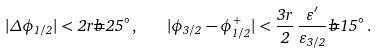Convert formula to latex. <formula><loc_0><loc_0><loc_500><loc_500>| \Delta \phi _ { 1 / 2 } | < 2 r \widehat { = } 2 5 ^ { \circ } \, , \quad | \phi _ { 3 / 2 } - \phi _ { 1 / 2 } ^ { + } | < \frac { 3 r } { 2 } \, \frac { \varepsilon ^ { \prime } } { \varepsilon _ { 3 / 2 } } \widehat { = } 1 5 ^ { \circ } \, .</formula> 